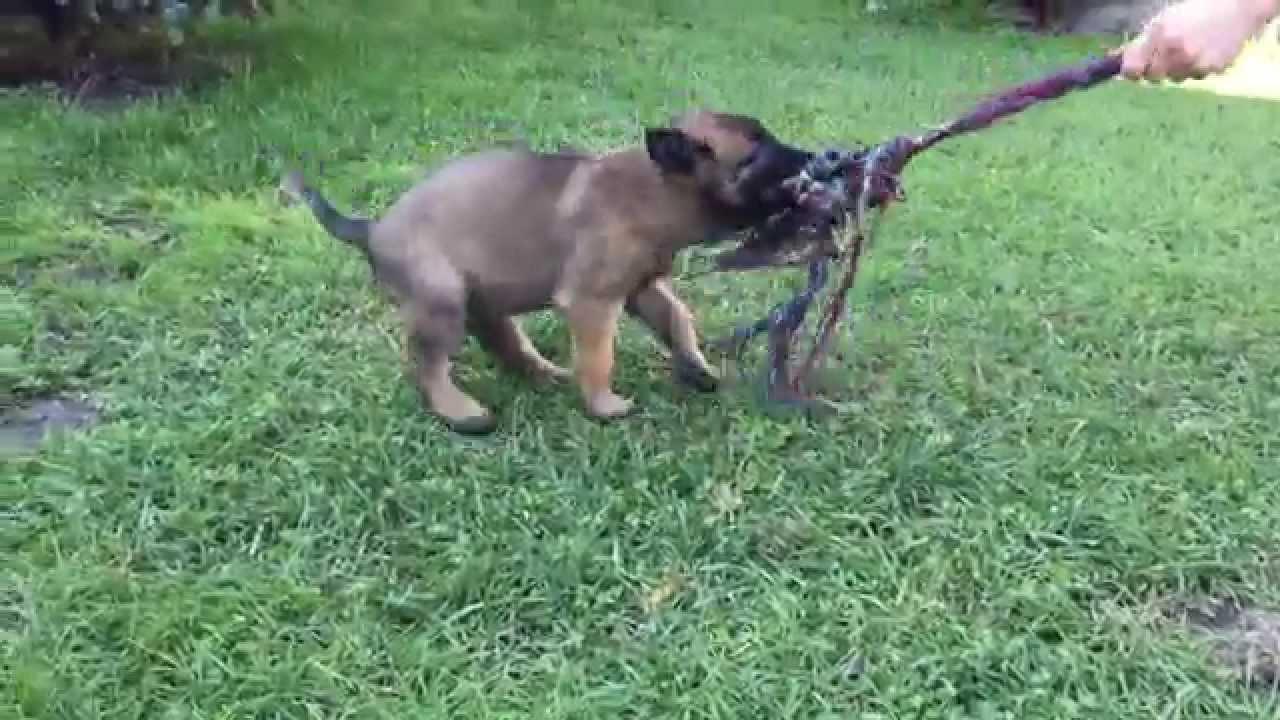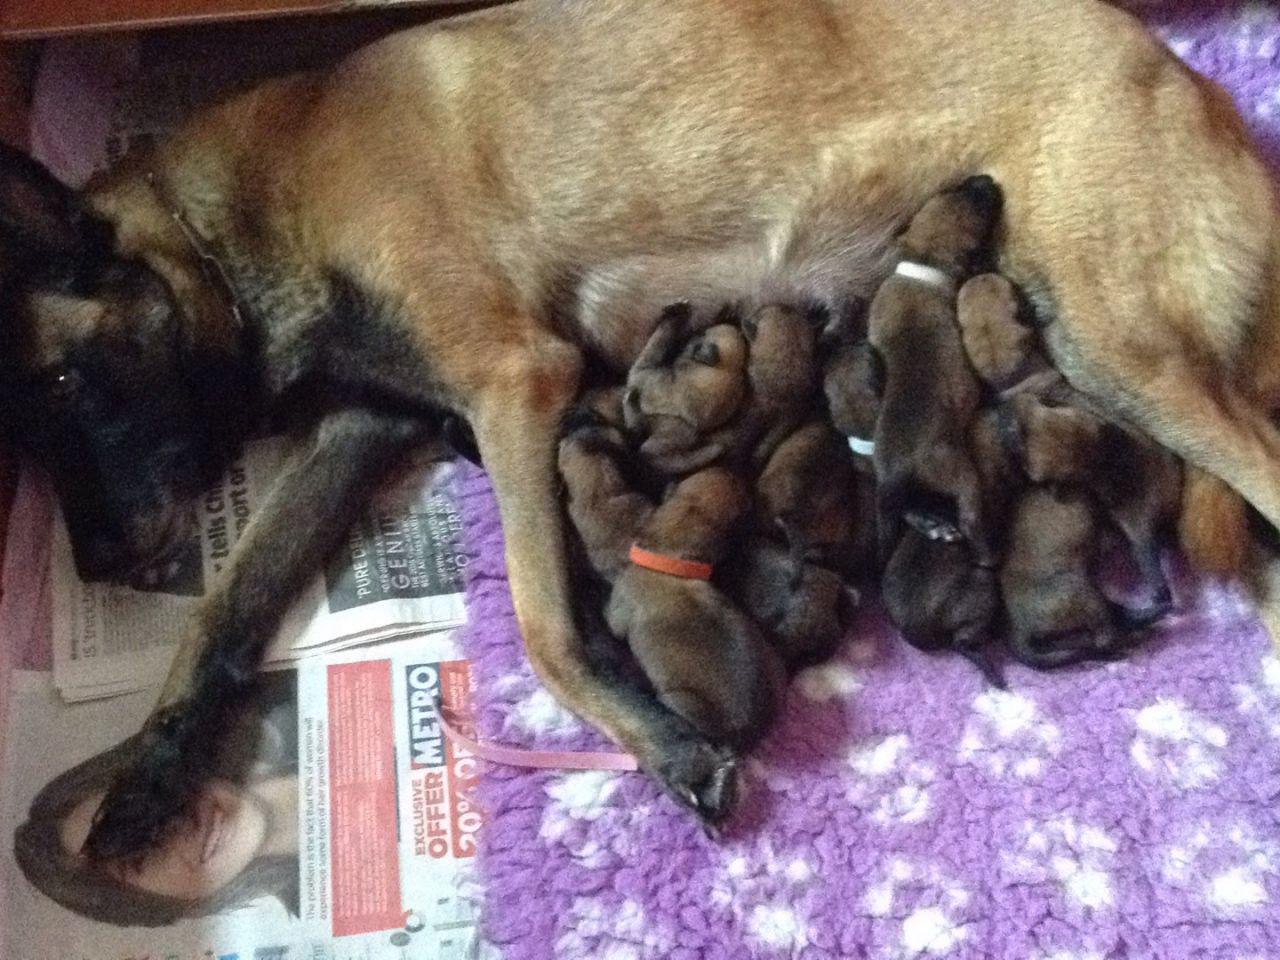The first image is the image on the left, the second image is the image on the right. Considering the images on both sides, is "Each image shows a pile of puppies, and at least one pile of puppies is surrounded by a wire enclosure." valid? Answer yes or no. No. The first image is the image on the left, the second image is the image on the right. For the images shown, is this caption "The puppies in at least one of the images are in a wired cage." true? Answer yes or no. No. 